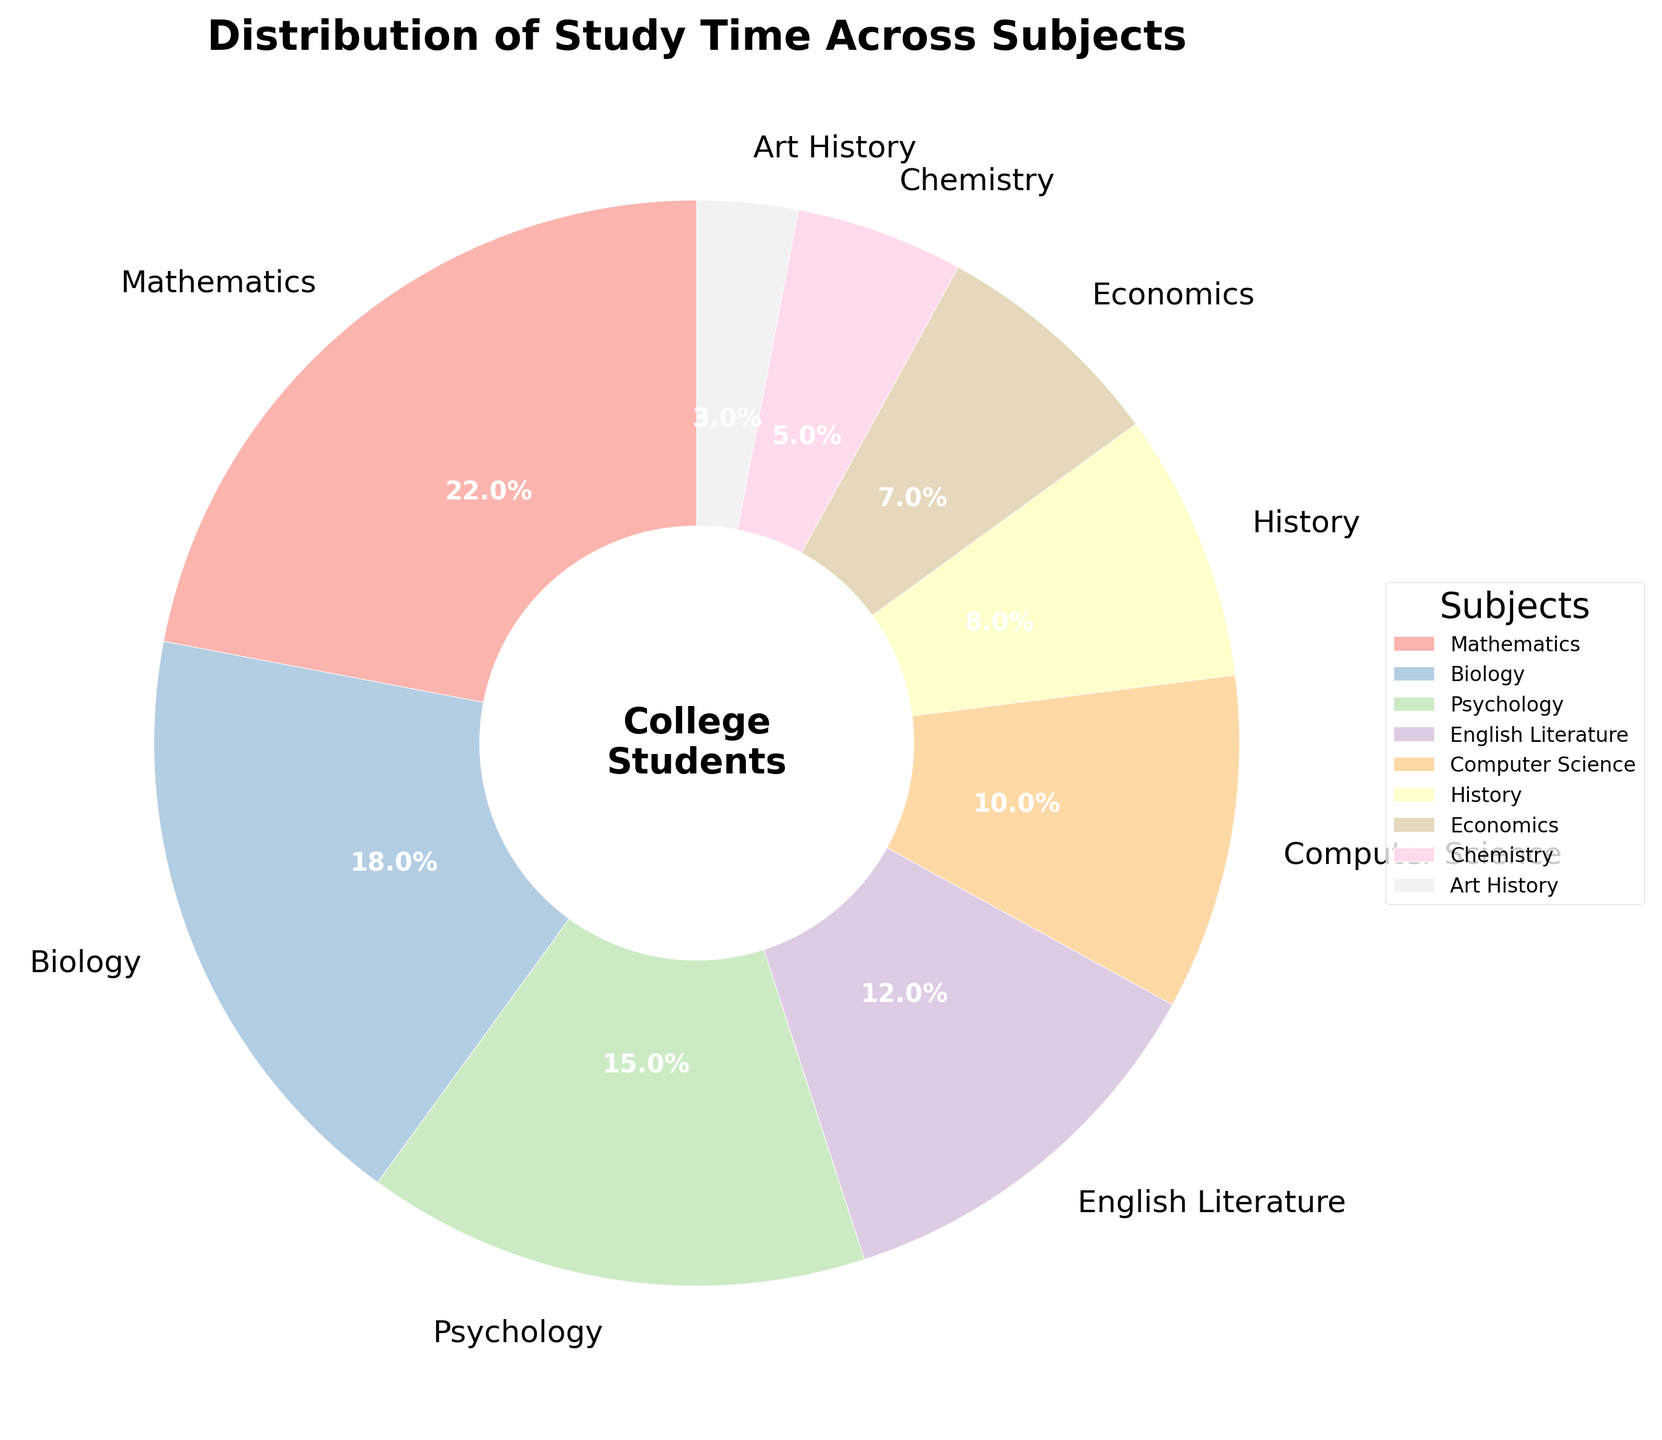What subject has the largest percentage of study time? The pie chart shows the percentage distribution of study time across different subjects. By directly observing the chart, you can see that Mathematics has the largest wedge.
Answer: Mathematics Which subject has the smallest percentage of study time? The smallest wedge in the pie chart corresponds to Art History. By inspecting the chart, it is clear that Art History takes up the smallest portion.
Answer: Art History What is the combined percentage of study time for Psychology and Biology? The pie chart displays the percentages for each subject. Psychology has 15% and Biology has 18%. Adding these two percentages gives 33%.
Answer: 33% Which subjects together make up less than 10% of the study time? By examining the individual percentages in the pie chart, the only subject with a percentage less than 10% is Chemistry, which has 5%, and Art History with 3%.
Answer: Chemistry and Art History What is the difference in percentage of study time between Mathematics and Computer Science? Mathematics accounts for 22% of study time, while Computer Science accounts for 10%. Subtracting 10 from 22 gives a difference of 12%.
Answer: 12% What percentage of study time do History and Economics together account for? The pie chart shows that History takes up 8% and Economics takes up 7%. Adding these two percentages results in 15%.
Answer: 15% Are there more subjects with a study time percentage above 10% or below 10%? Count the subjects above 10% (Mathematics, Biology, Psychology, English Literature, Computer Science) and those below 10% (History, Economics, Chemistry, Art History). There are 5 subjects above 10% and 4 subjects below 10%.
Answer: Above 10% Which three subjects have the closest percentages of study time? Looking at the pie chart, Psychology (15%), English Literature (12%), and Computer Science (10%) have relatively close percentages compared to other subjects.
Answer: Psychology, English Literature, and Computer Science Which color represents the subject with the second highest percentage of study time? The subject with the second highest percentage is Biology, which accounts for 18%. Identify the color representing Biology in the pie chart.
Answer: The color of the Biology wedge What is the average percentage of study time for Mathematics, Economics, and Chemistry? Mathematics has 22%, Economics has 7%, and Chemistry has 5%. Add these percentages (22 + 7 + 5 = 34) and divide by 3 to get the average (34 ÷ 3 ≈ 11.33).
Answer: 11.3% 